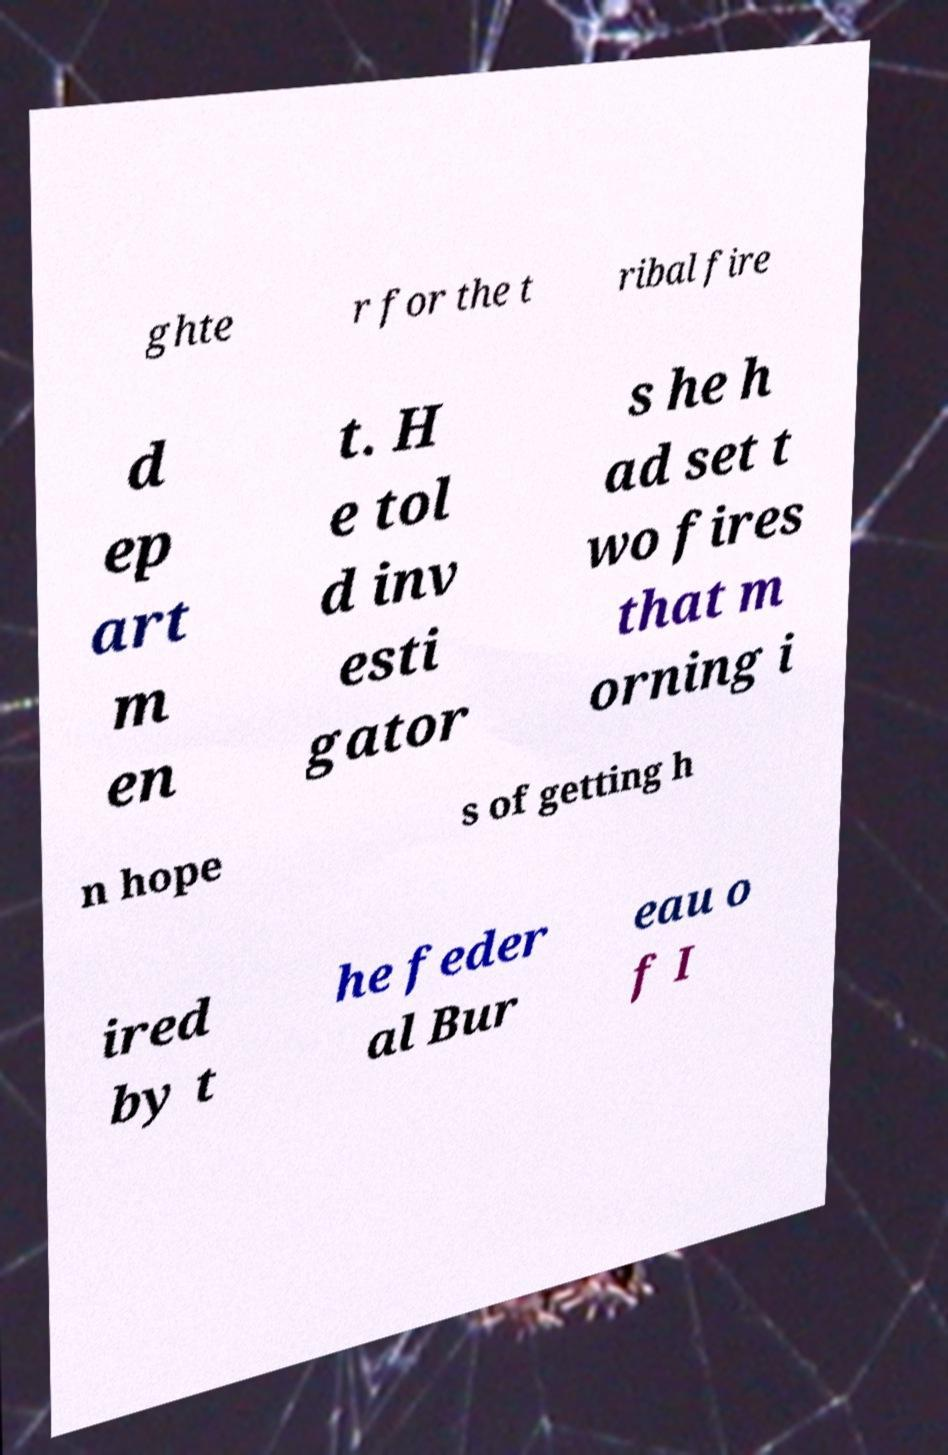I need the written content from this picture converted into text. Can you do that? ghte r for the t ribal fire d ep art m en t. H e tol d inv esti gator s he h ad set t wo fires that m orning i n hope s of getting h ired by t he feder al Bur eau o f I 